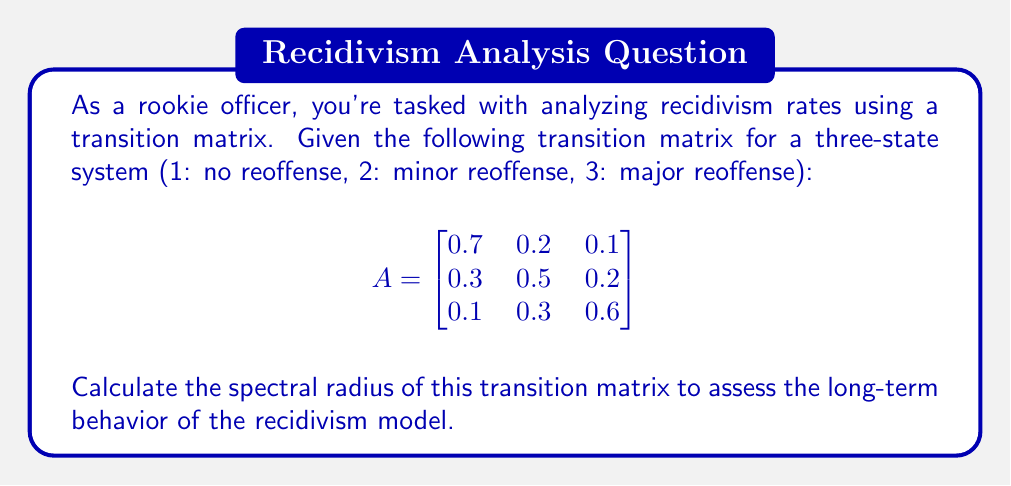What is the answer to this math problem? To calculate the spectral radius of the transition matrix, we need to follow these steps:

1) First, we need to find the eigenvalues of the matrix. The characteristic equation is:

   $$\det(A - \lambda I) = 0$$

2) Expanding this:

   $$\begin{vmatrix}
   0.7-\lambda & 0.2 & 0.1 \\
   0.3 & 0.5-\lambda & 0.2 \\
   0.1 & 0.3 & 0.6-\lambda
   \end{vmatrix} = 0$$

3) This gives us the cubic equation:

   $$-\lambda^3 + 1.8\lambda^2 - 0.93\lambda + 0.13 = 0$$

4) Solving this equation (using a calculator or computer algebra system) gives us the eigenvalues:

   $$\lambda_1 \approx 1, \lambda_2 \approx 0.5, \lambda_3 \approx 0.3$$

5) The spectral radius is defined as the maximum absolute value of the eigenvalues:

   $$\rho(A) = \max_{i} |\lambda_i|$$

6) In this case, the largest eigenvalue in absolute value is approximately 1.

Therefore, the spectral radius of the transition matrix is 1.
Answer: $\rho(A) = 1$ 